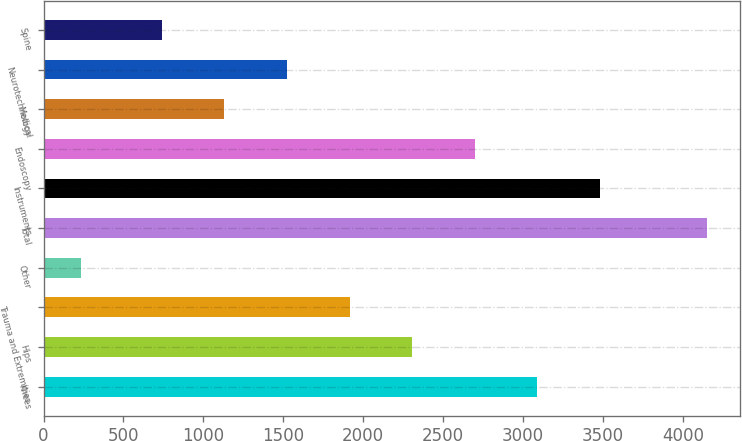Convert chart. <chart><loc_0><loc_0><loc_500><loc_500><bar_chart><fcel>Knees<fcel>Hips<fcel>Trauma and Extremities<fcel>Other<fcel>Total<fcel>Instruments<fcel>Endoscopy<fcel>Medical<fcel>Neurotechnology<fcel>Spine<nl><fcel>3090.2<fcel>2306.8<fcel>1915.1<fcel>236<fcel>4153<fcel>3481.9<fcel>2698.5<fcel>1131.7<fcel>1523.4<fcel>740<nl></chart> 